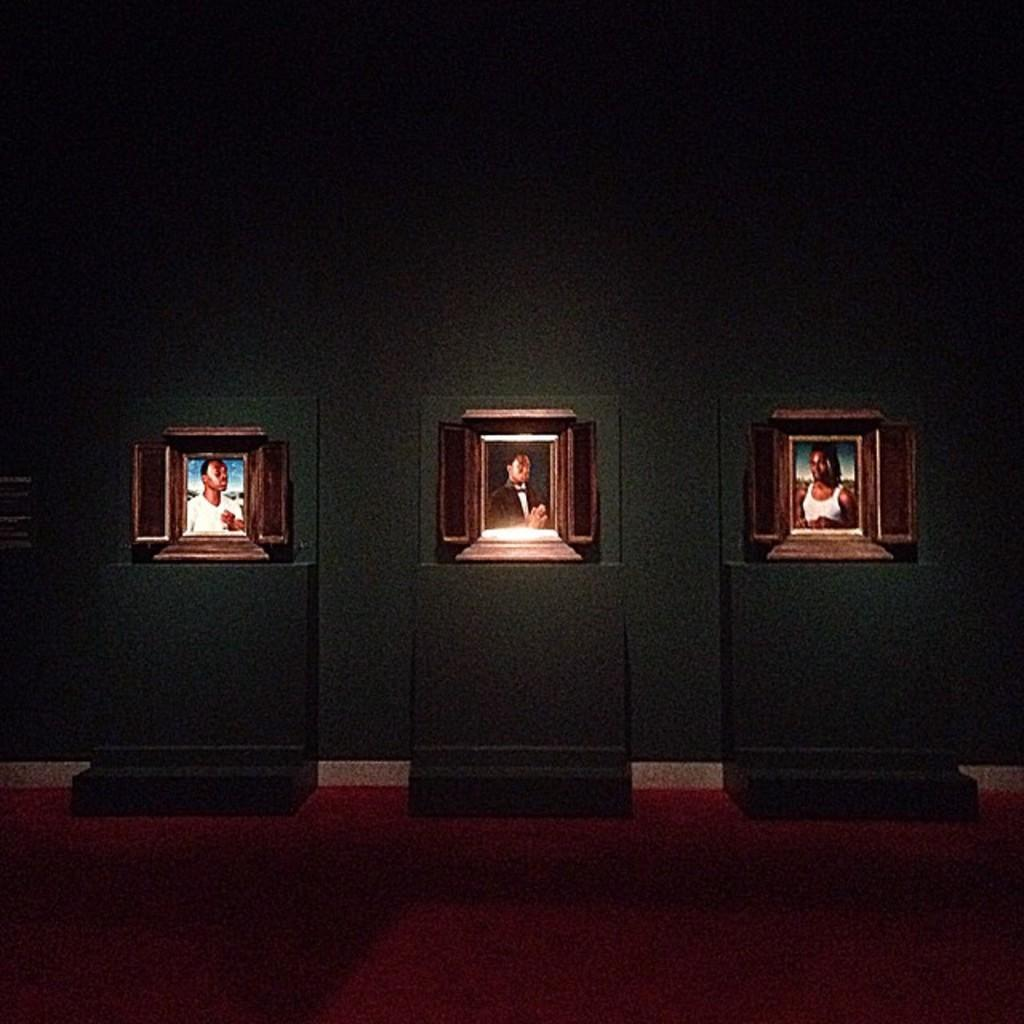How many photo frames are in the image? There are three photo frames in the image. What are the photo frames placed on? The photo frames are on three objects. What can be seen in the background of the image? There is a wall visible in the background of the image. What is visible at the bottom of the image? The floor is visible at the bottom of the image. What channel is the sheet being used on in the image? There is no channel or sheet present in the image. 